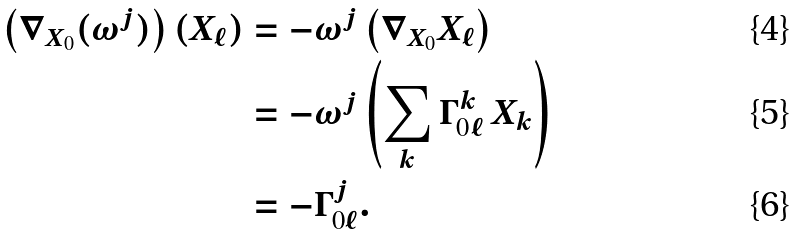Convert formula to latex. <formula><loc_0><loc_0><loc_500><loc_500>\left ( \nabla _ { X _ { 0 } } ( \omega ^ { j } ) \right ) ( X _ { \ell } ) & = - \omega ^ { j } \left ( \nabla _ { X _ { 0 } } X _ { \ell } \right ) \\ & = - \omega ^ { j } \left ( \sum _ { k } \Gamma ^ { k } _ { 0 \ell } \, X _ { k } \right ) \\ & = - \Gamma ^ { j } _ { 0 \ell } .</formula> 